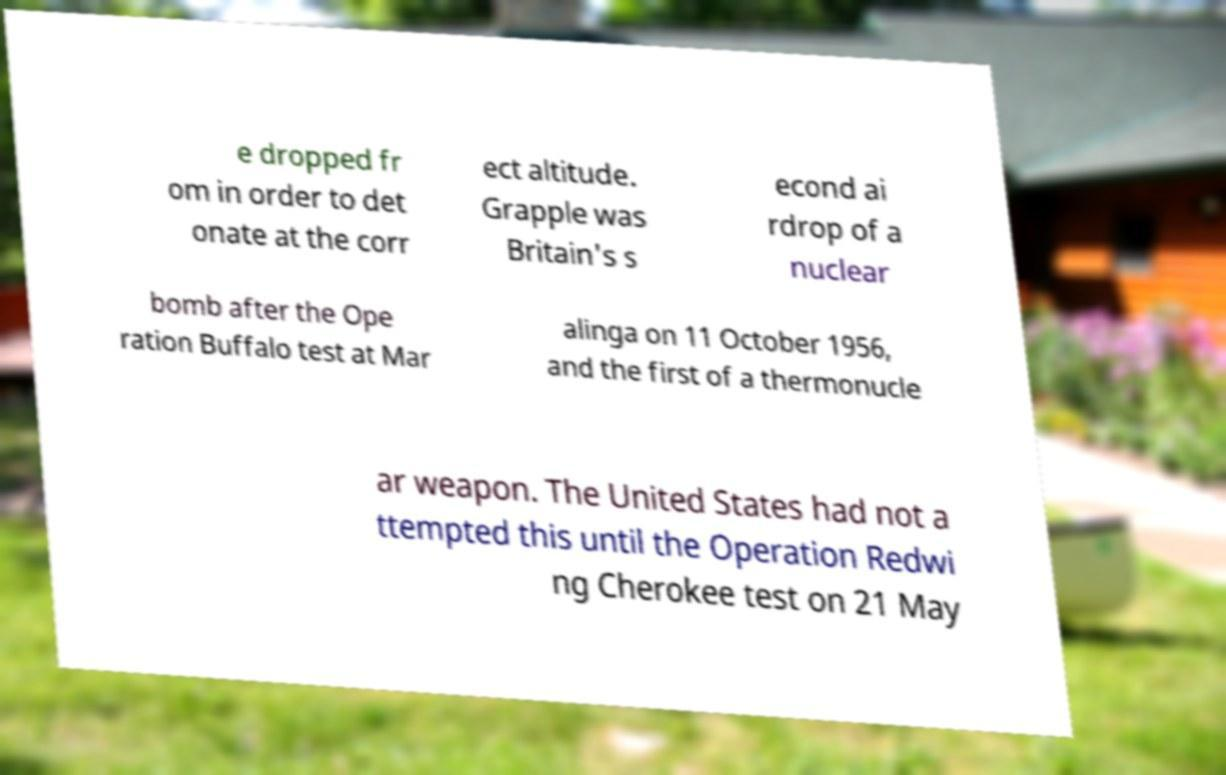I need the written content from this picture converted into text. Can you do that? e dropped fr om in order to det onate at the corr ect altitude. Grapple was Britain's s econd ai rdrop of a nuclear bomb after the Ope ration Buffalo test at Mar alinga on 11 October 1956, and the first of a thermonucle ar weapon. The United States had not a ttempted this until the Operation Redwi ng Cherokee test on 21 May 